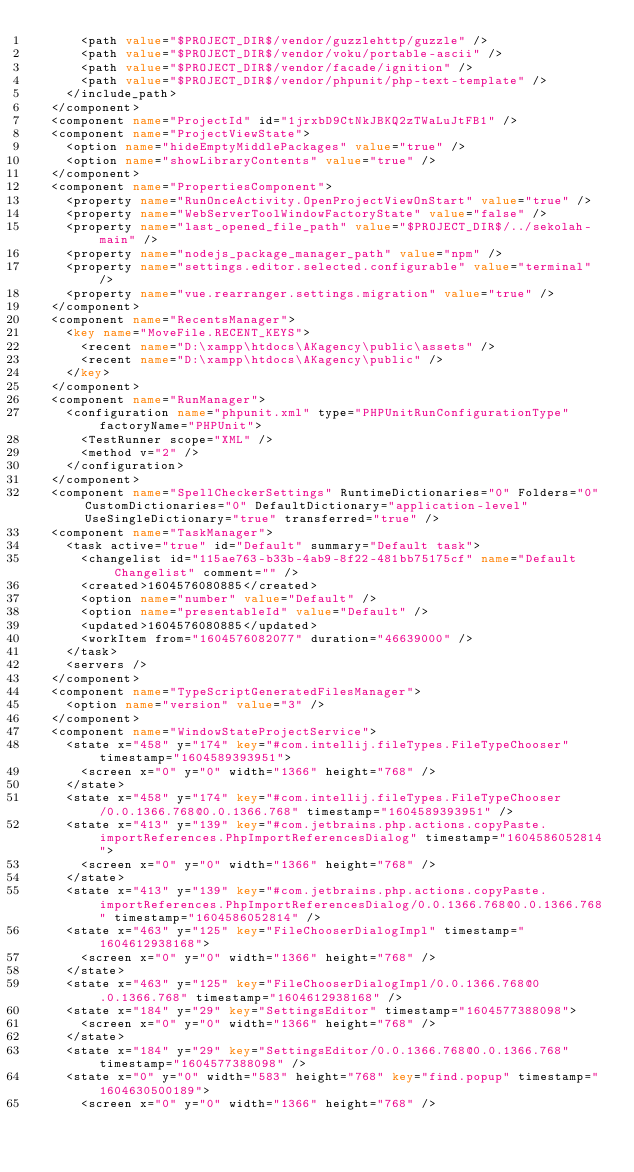<code> <loc_0><loc_0><loc_500><loc_500><_XML_>      <path value="$PROJECT_DIR$/vendor/guzzlehttp/guzzle" />
      <path value="$PROJECT_DIR$/vendor/voku/portable-ascii" />
      <path value="$PROJECT_DIR$/vendor/facade/ignition" />
      <path value="$PROJECT_DIR$/vendor/phpunit/php-text-template" />
    </include_path>
  </component>
  <component name="ProjectId" id="1jrxbD9CtNkJBKQ2zTWaLuJtFB1" />
  <component name="ProjectViewState">
    <option name="hideEmptyMiddlePackages" value="true" />
    <option name="showLibraryContents" value="true" />
  </component>
  <component name="PropertiesComponent">
    <property name="RunOnceActivity.OpenProjectViewOnStart" value="true" />
    <property name="WebServerToolWindowFactoryState" value="false" />
    <property name="last_opened_file_path" value="$PROJECT_DIR$/../sekolah-main" />
    <property name="nodejs_package_manager_path" value="npm" />
    <property name="settings.editor.selected.configurable" value="terminal" />
    <property name="vue.rearranger.settings.migration" value="true" />
  </component>
  <component name="RecentsManager">
    <key name="MoveFile.RECENT_KEYS">
      <recent name="D:\xampp\htdocs\AKagency\public\assets" />
      <recent name="D:\xampp\htdocs\AKagency\public" />
    </key>
  </component>
  <component name="RunManager">
    <configuration name="phpunit.xml" type="PHPUnitRunConfigurationType" factoryName="PHPUnit">
      <TestRunner scope="XML" />
      <method v="2" />
    </configuration>
  </component>
  <component name="SpellCheckerSettings" RuntimeDictionaries="0" Folders="0" CustomDictionaries="0" DefaultDictionary="application-level" UseSingleDictionary="true" transferred="true" />
  <component name="TaskManager">
    <task active="true" id="Default" summary="Default task">
      <changelist id="115ae763-b33b-4ab9-8f22-481bb75175cf" name="Default Changelist" comment="" />
      <created>1604576080885</created>
      <option name="number" value="Default" />
      <option name="presentableId" value="Default" />
      <updated>1604576080885</updated>
      <workItem from="1604576082077" duration="46639000" />
    </task>
    <servers />
  </component>
  <component name="TypeScriptGeneratedFilesManager">
    <option name="version" value="3" />
  </component>
  <component name="WindowStateProjectService">
    <state x="458" y="174" key="#com.intellij.fileTypes.FileTypeChooser" timestamp="1604589393951">
      <screen x="0" y="0" width="1366" height="768" />
    </state>
    <state x="458" y="174" key="#com.intellij.fileTypes.FileTypeChooser/0.0.1366.768@0.0.1366.768" timestamp="1604589393951" />
    <state x="413" y="139" key="#com.jetbrains.php.actions.copyPaste.importReferences.PhpImportReferencesDialog" timestamp="1604586052814">
      <screen x="0" y="0" width="1366" height="768" />
    </state>
    <state x="413" y="139" key="#com.jetbrains.php.actions.copyPaste.importReferences.PhpImportReferencesDialog/0.0.1366.768@0.0.1366.768" timestamp="1604586052814" />
    <state x="463" y="125" key="FileChooserDialogImpl" timestamp="1604612938168">
      <screen x="0" y="0" width="1366" height="768" />
    </state>
    <state x="463" y="125" key="FileChooserDialogImpl/0.0.1366.768@0.0.1366.768" timestamp="1604612938168" />
    <state x="184" y="29" key="SettingsEditor" timestamp="1604577388098">
      <screen x="0" y="0" width="1366" height="768" />
    </state>
    <state x="184" y="29" key="SettingsEditor/0.0.1366.768@0.0.1366.768" timestamp="1604577388098" />
    <state x="0" y="0" width="583" height="768" key="find.popup" timestamp="1604630500189">
      <screen x="0" y="0" width="1366" height="768" /></code> 